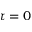Convert formula to latex. <formula><loc_0><loc_0><loc_500><loc_500>\tau = 0</formula> 